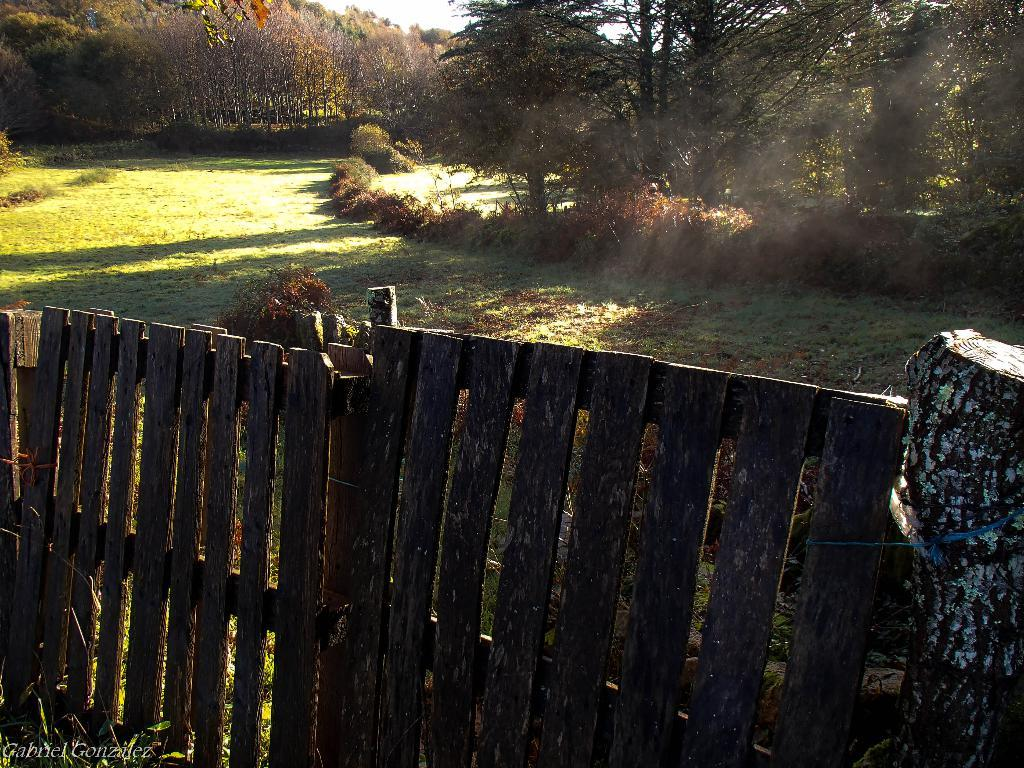What type of terrain is visible in the image? The image contains land full of grass. What type of vegetation can be seen in the image? There are trees in the image. What type of fencing is present in the image? There is wooden fencing in the image. What type of pipe is visible in the image? There is no pipe present in the image. What nation is represented by the flag in the image? There is no flag present in the image. 